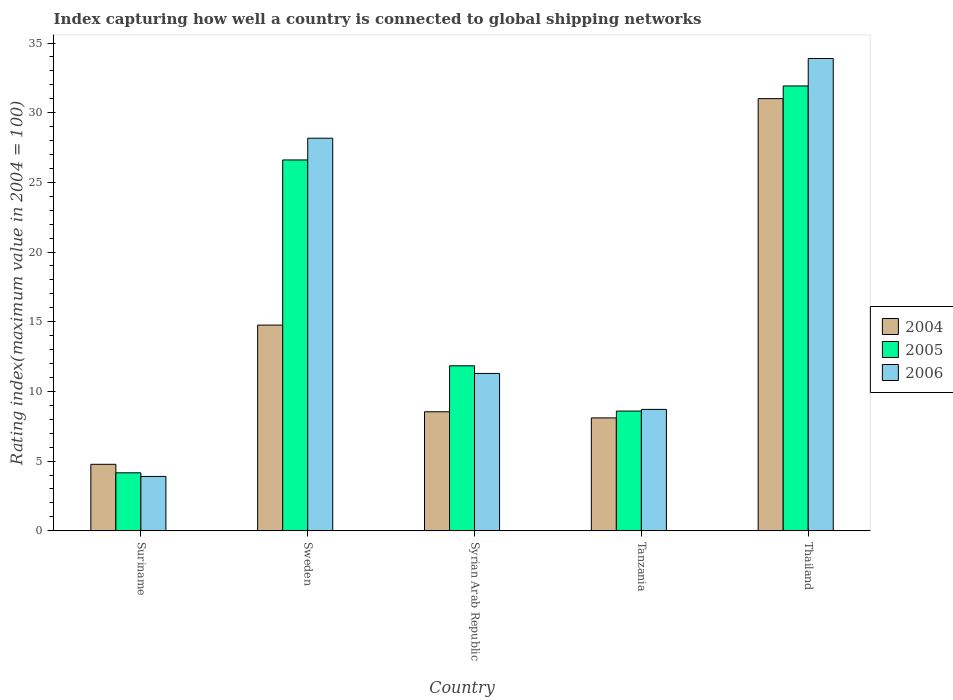How many different coloured bars are there?
Your response must be concise. 3. How many groups of bars are there?
Offer a very short reply. 5. Are the number of bars per tick equal to the number of legend labels?
Keep it short and to the point. Yes. How many bars are there on the 3rd tick from the left?
Offer a terse response. 3. How many bars are there on the 4th tick from the right?
Provide a short and direct response. 3. What is the label of the 1st group of bars from the left?
Provide a short and direct response. Suriname. What is the rating index in 2005 in Tanzania?
Keep it short and to the point. 8.59. Across all countries, what is the maximum rating index in 2006?
Give a very brief answer. 33.89. Across all countries, what is the minimum rating index in 2005?
Provide a succinct answer. 4.16. In which country was the rating index in 2005 maximum?
Offer a terse response. Thailand. In which country was the rating index in 2006 minimum?
Make the answer very short. Suriname. What is the total rating index in 2006 in the graph?
Your response must be concise. 85.96. What is the difference between the rating index in 2005 in Tanzania and that in Thailand?
Offer a very short reply. -23.33. What is the difference between the rating index in 2006 in Syrian Arab Republic and the rating index in 2005 in Tanzania?
Make the answer very short. 2.7. What is the average rating index in 2006 per country?
Give a very brief answer. 17.19. What is the difference between the rating index of/in 2005 and rating index of/in 2006 in Sweden?
Your answer should be compact. -1.56. What is the ratio of the rating index in 2006 in Sweden to that in Tanzania?
Keep it short and to the point. 3.23. Is the difference between the rating index in 2005 in Sweden and Thailand greater than the difference between the rating index in 2006 in Sweden and Thailand?
Provide a succinct answer. Yes. What is the difference between the highest and the second highest rating index in 2004?
Your answer should be very brief. -6.22. What is the difference between the highest and the lowest rating index in 2004?
Your response must be concise. 26.24. Is the sum of the rating index in 2006 in Syrian Arab Republic and Thailand greater than the maximum rating index in 2004 across all countries?
Provide a succinct answer. Yes. What does the 3rd bar from the left in Suriname represents?
Offer a terse response. 2006. What does the 2nd bar from the right in Suriname represents?
Your response must be concise. 2005. Are all the bars in the graph horizontal?
Ensure brevity in your answer.  No. How many countries are there in the graph?
Your answer should be compact. 5. What is the difference between two consecutive major ticks on the Y-axis?
Your response must be concise. 5. Does the graph contain any zero values?
Offer a terse response. No. Where does the legend appear in the graph?
Keep it short and to the point. Center right. How many legend labels are there?
Provide a short and direct response. 3. How are the legend labels stacked?
Give a very brief answer. Vertical. What is the title of the graph?
Your answer should be very brief. Index capturing how well a country is connected to global shipping networks. Does "1974" appear as one of the legend labels in the graph?
Make the answer very short. No. What is the label or title of the Y-axis?
Offer a very short reply. Rating index(maximum value in 2004 = 100). What is the Rating index(maximum value in 2004 = 100) of 2004 in Suriname?
Provide a short and direct response. 4.77. What is the Rating index(maximum value in 2004 = 100) of 2005 in Suriname?
Offer a terse response. 4.16. What is the Rating index(maximum value in 2004 = 100) in 2006 in Suriname?
Your response must be concise. 3.9. What is the Rating index(maximum value in 2004 = 100) of 2004 in Sweden?
Provide a short and direct response. 14.76. What is the Rating index(maximum value in 2004 = 100) of 2005 in Sweden?
Your answer should be compact. 26.61. What is the Rating index(maximum value in 2004 = 100) of 2006 in Sweden?
Provide a succinct answer. 28.17. What is the Rating index(maximum value in 2004 = 100) of 2004 in Syrian Arab Republic?
Keep it short and to the point. 8.54. What is the Rating index(maximum value in 2004 = 100) of 2005 in Syrian Arab Republic?
Your answer should be very brief. 11.84. What is the Rating index(maximum value in 2004 = 100) of 2006 in Syrian Arab Republic?
Offer a very short reply. 11.29. What is the Rating index(maximum value in 2004 = 100) in 2004 in Tanzania?
Ensure brevity in your answer.  8.1. What is the Rating index(maximum value in 2004 = 100) in 2005 in Tanzania?
Your response must be concise. 8.59. What is the Rating index(maximum value in 2004 = 100) of 2006 in Tanzania?
Ensure brevity in your answer.  8.71. What is the Rating index(maximum value in 2004 = 100) of 2004 in Thailand?
Your answer should be very brief. 31.01. What is the Rating index(maximum value in 2004 = 100) in 2005 in Thailand?
Your answer should be very brief. 31.92. What is the Rating index(maximum value in 2004 = 100) in 2006 in Thailand?
Provide a succinct answer. 33.89. Across all countries, what is the maximum Rating index(maximum value in 2004 = 100) in 2004?
Your answer should be very brief. 31.01. Across all countries, what is the maximum Rating index(maximum value in 2004 = 100) of 2005?
Your answer should be compact. 31.92. Across all countries, what is the maximum Rating index(maximum value in 2004 = 100) in 2006?
Offer a very short reply. 33.89. Across all countries, what is the minimum Rating index(maximum value in 2004 = 100) in 2004?
Offer a terse response. 4.77. Across all countries, what is the minimum Rating index(maximum value in 2004 = 100) in 2005?
Ensure brevity in your answer.  4.16. Across all countries, what is the minimum Rating index(maximum value in 2004 = 100) in 2006?
Make the answer very short. 3.9. What is the total Rating index(maximum value in 2004 = 100) of 2004 in the graph?
Ensure brevity in your answer.  67.18. What is the total Rating index(maximum value in 2004 = 100) of 2005 in the graph?
Give a very brief answer. 83.12. What is the total Rating index(maximum value in 2004 = 100) in 2006 in the graph?
Give a very brief answer. 85.96. What is the difference between the Rating index(maximum value in 2004 = 100) in 2004 in Suriname and that in Sweden?
Provide a succinct answer. -9.99. What is the difference between the Rating index(maximum value in 2004 = 100) of 2005 in Suriname and that in Sweden?
Your answer should be compact. -22.45. What is the difference between the Rating index(maximum value in 2004 = 100) in 2006 in Suriname and that in Sweden?
Your answer should be compact. -24.27. What is the difference between the Rating index(maximum value in 2004 = 100) of 2004 in Suriname and that in Syrian Arab Republic?
Keep it short and to the point. -3.77. What is the difference between the Rating index(maximum value in 2004 = 100) of 2005 in Suriname and that in Syrian Arab Republic?
Your answer should be compact. -7.68. What is the difference between the Rating index(maximum value in 2004 = 100) of 2006 in Suriname and that in Syrian Arab Republic?
Make the answer very short. -7.39. What is the difference between the Rating index(maximum value in 2004 = 100) of 2004 in Suriname and that in Tanzania?
Provide a succinct answer. -3.33. What is the difference between the Rating index(maximum value in 2004 = 100) of 2005 in Suriname and that in Tanzania?
Keep it short and to the point. -4.43. What is the difference between the Rating index(maximum value in 2004 = 100) in 2006 in Suriname and that in Tanzania?
Provide a short and direct response. -4.81. What is the difference between the Rating index(maximum value in 2004 = 100) in 2004 in Suriname and that in Thailand?
Make the answer very short. -26.24. What is the difference between the Rating index(maximum value in 2004 = 100) of 2005 in Suriname and that in Thailand?
Give a very brief answer. -27.76. What is the difference between the Rating index(maximum value in 2004 = 100) of 2006 in Suriname and that in Thailand?
Give a very brief answer. -29.99. What is the difference between the Rating index(maximum value in 2004 = 100) in 2004 in Sweden and that in Syrian Arab Republic?
Your answer should be compact. 6.22. What is the difference between the Rating index(maximum value in 2004 = 100) of 2005 in Sweden and that in Syrian Arab Republic?
Your answer should be very brief. 14.77. What is the difference between the Rating index(maximum value in 2004 = 100) of 2006 in Sweden and that in Syrian Arab Republic?
Your answer should be very brief. 16.88. What is the difference between the Rating index(maximum value in 2004 = 100) in 2004 in Sweden and that in Tanzania?
Provide a succinct answer. 6.66. What is the difference between the Rating index(maximum value in 2004 = 100) in 2005 in Sweden and that in Tanzania?
Provide a succinct answer. 18.02. What is the difference between the Rating index(maximum value in 2004 = 100) in 2006 in Sweden and that in Tanzania?
Give a very brief answer. 19.46. What is the difference between the Rating index(maximum value in 2004 = 100) of 2004 in Sweden and that in Thailand?
Provide a short and direct response. -16.25. What is the difference between the Rating index(maximum value in 2004 = 100) in 2005 in Sweden and that in Thailand?
Make the answer very short. -5.31. What is the difference between the Rating index(maximum value in 2004 = 100) of 2006 in Sweden and that in Thailand?
Your response must be concise. -5.72. What is the difference between the Rating index(maximum value in 2004 = 100) of 2004 in Syrian Arab Republic and that in Tanzania?
Provide a short and direct response. 0.44. What is the difference between the Rating index(maximum value in 2004 = 100) of 2005 in Syrian Arab Republic and that in Tanzania?
Your response must be concise. 3.25. What is the difference between the Rating index(maximum value in 2004 = 100) of 2006 in Syrian Arab Republic and that in Tanzania?
Your answer should be compact. 2.58. What is the difference between the Rating index(maximum value in 2004 = 100) of 2004 in Syrian Arab Republic and that in Thailand?
Provide a short and direct response. -22.47. What is the difference between the Rating index(maximum value in 2004 = 100) in 2005 in Syrian Arab Republic and that in Thailand?
Offer a very short reply. -20.08. What is the difference between the Rating index(maximum value in 2004 = 100) in 2006 in Syrian Arab Republic and that in Thailand?
Offer a very short reply. -22.6. What is the difference between the Rating index(maximum value in 2004 = 100) in 2004 in Tanzania and that in Thailand?
Your answer should be compact. -22.91. What is the difference between the Rating index(maximum value in 2004 = 100) in 2005 in Tanzania and that in Thailand?
Offer a very short reply. -23.33. What is the difference between the Rating index(maximum value in 2004 = 100) in 2006 in Tanzania and that in Thailand?
Make the answer very short. -25.18. What is the difference between the Rating index(maximum value in 2004 = 100) in 2004 in Suriname and the Rating index(maximum value in 2004 = 100) in 2005 in Sweden?
Ensure brevity in your answer.  -21.84. What is the difference between the Rating index(maximum value in 2004 = 100) in 2004 in Suriname and the Rating index(maximum value in 2004 = 100) in 2006 in Sweden?
Provide a succinct answer. -23.4. What is the difference between the Rating index(maximum value in 2004 = 100) in 2005 in Suriname and the Rating index(maximum value in 2004 = 100) in 2006 in Sweden?
Give a very brief answer. -24.01. What is the difference between the Rating index(maximum value in 2004 = 100) in 2004 in Suriname and the Rating index(maximum value in 2004 = 100) in 2005 in Syrian Arab Republic?
Keep it short and to the point. -7.07. What is the difference between the Rating index(maximum value in 2004 = 100) in 2004 in Suriname and the Rating index(maximum value in 2004 = 100) in 2006 in Syrian Arab Republic?
Keep it short and to the point. -6.52. What is the difference between the Rating index(maximum value in 2004 = 100) of 2005 in Suriname and the Rating index(maximum value in 2004 = 100) of 2006 in Syrian Arab Republic?
Your answer should be compact. -7.13. What is the difference between the Rating index(maximum value in 2004 = 100) of 2004 in Suriname and the Rating index(maximum value in 2004 = 100) of 2005 in Tanzania?
Make the answer very short. -3.82. What is the difference between the Rating index(maximum value in 2004 = 100) of 2004 in Suriname and the Rating index(maximum value in 2004 = 100) of 2006 in Tanzania?
Make the answer very short. -3.94. What is the difference between the Rating index(maximum value in 2004 = 100) in 2005 in Suriname and the Rating index(maximum value in 2004 = 100) in 2006 in Tanzania?
Offer a very short reply. -4.55. What is the difference between the Rating index(maximum value in 2004 = 100) in 2004 in Suriname and the Rating index(maximum value in 2004 = 100) in 2005 in Thailand?
Keep it short and to the point. -27.15. What is the difference between the Rating index(maximum value in 2004 = 100) of 2004 in Suriname and the Rating index(maximum value in 2004 = 100) of 2006 in Thailand?
Your answer should be very brief. -29.12. What is the difference between the Rating index(maximum value in 2004 = 100) of 2005 in Suriname and the Rating index(maximum value in 2004 = 100) of 2006 in Thailand?
Provide a succinct answer. -29.73. What is the difference between the Rating index(maximum value in 2004 = 100) of 2004 in Sweden and the Rating index(maximum value in 2004 = 100) of 2005 in Syrian Arab Republic?
Offer a terse response. 2.92. What is the difference between the Rating index(maximum value in 2004 = 100) in 2004 in Sweden and the Rating index(maximum value in 2004 = 100) in 2006 in Syrian Arab Republic?
Keep it short and to the point. 3.47. What is the difference between the Rating index(maximum value in 2004 = 100) in 2005 in Sweden and the Rating index(maximum value in 2004 = 100) in 2006 in Syrian Arab Republic?
Offer a terse response. 15.32. What is the difference between the Rating index(maximum value in 2004 = 100) of 2004 in Sweden and the Rating index(maximum value in 2004 = 100) of 2005 in Tanzania?
Your response must be concise. 6.17. What is the difference between the Rating index(maximum value in 2004 = 100) in 2004 in Sweden and the Rating index(maximum value in 2004 = 100) in 2006 in Tanzania?
Give a very brief answer. 6.05. What is the difference between the Rating index(maximum value in 2004 = 100) in 2004 in Sweden and the Rating index(maximum value in 2004 = 100) in 2005 in Thailand?
Make the answer very short. -17.16. What is the difference between the Rating index(maximum value in 2004 = 100) of 2004 in Sweden and the Rating index(maximum value in 2004 = 100) of 2006 in Thailand?
Keep it short and to the point. -19.13. What is the difference between the Rating index(maximum value in 2004 = 100) of 2005 in Sweden and the Rating index(maximum value in 2004 = 100) of 2006 in Thailand?
Offer a very short reply. -7.28. What is the difference between the Rating index(maximum value in 2004 = 100) in 2004 in Syrian Arab Republic and the Rating index(maximum value in 2004 = 100) in 2006 in Tanzania?
Provide a succinct answer. -0.17. What is the difference between the Rating index(maximum value in 2004 = 100) in 2005 in Syrian Arab Republic and the Rating index(maximum value in 2004 = 100) in 2006 in Tanzania?
Give a very brief answer. 3.13. What is the difference between the Rating index(maximum value in 2004 = 100) in 2004 in Syrian Arab Republic and the Rating index(maximum value in 2004 = 100) in 2005 in Thailand?
Give a very brief answer. -23.38. What is the difference between the Rating index(maximum value in 2004 = 100) of 2004 in Syrian Arab Republic and the Rating index(maximum value in 2004 = 100) of 2006 in Thailand?
Offer a very short reply. -25.35. What is the difference between the Rating index(maximum value in 2004 = 100) in 2005 in Syrian Arab Republic and the Rating index(maximum value in 2004 = 100) in 2006 in Thailand?
Provide a succinct answer. -22.05. What is the difference between the Rating index(maximum value in 2004 = 100) in 2004 in Tanzania and the Rating index(maximum value in 2004 = 100) in 2005 in Thailand?
Your answer should be very brief. -23.82. What is the difference between the Rating index(maximum value in 2004 = 100) of 2004 in Tanzania and the Rating index(maximum value in 2004 = 100) of 2006 in Thailand?
Your answer should be very brief. -25.79. What is the difference between the Rating index(maximum value in 2004 = 100) in 2005 in Tanzania and the Rating index(maximum value in 2004 = 100) in 2006 in Thailand?
Your answer should be compact. -25.3. What is the average Rating index(maximum value in 2004 = 100) of 2004 per country?
Your answer should be compact. 13.44. What is the average Rating index(maximum value in 2004 = 100) in 2005 per country?
Provide a succinct answer. 16.62. What is the average Rating index(maximum value in 2004 = 100) of 2006 per country?
Make the answer very short. 17.19. What is the difference between the Rating index(maximum value in 2004 = 100) of 2004 and Rating index(maximum value in 2004 = 100) of 2005 in Suriname?
Make the answer very short. 0.61. What is the difference between the Rating index(maximum value in 2004 = 100) in 2004 and Rating index(maximum value in 2004 = 100) in 2006 in Suriname?
Give a very brief answer. 0.87. What is the difference between the Rating index(maximum value in 2004 = 100) of 2005 and Rating index(maximum value in 2004 = 100) of 2006 in Suriname?
Provide a short and direct response. 0.26. What is the difference between the Rating index(maximum value in 2004 = 100) in 2004 and Rating index(maximum value in 2004 = 100) in 2005 in Sweden?
Ensure brevity in your answer.  -11.85. What is the difference between the Rating index(maximum value in 2004 = 100) of 2004 and Rating index(maximum value in 2004 = 100) of 2006 in Sweden?
Provide a short and direct response. -13.41. What is the difference between the Rating index(maximum value in 2004 = 100) in 2005 and Rating index(maximum value in 2004 = 100) in 2006 in Sweden?
Offer a very short reply. -1.56. What is the difference between the Rating index(maximum value in 2004 = 100) in 2004 and Rating index(maximum value in 2004 = 100) in 2006 in Syrian Arab Republic?
Provide a succinct answer. -2.75. What is the difference between the Rating index(maximum value in 2004 = 100) of 2005 and Rating index(maximum value in 2004 = 100) of 2006 in Syrian Arab Republic?
Ensure brevity in your answer.  0.55. What is the difference between the Rating index(maximum value in 2004 = 100) of 2004 and Rating index(maximum value in 2004 = 100) of 2005 in Tanzania?
Your answer should be very brief. -0.49. What is the difference between the Rating index(maximum value in 2004 = 100) of 2004 and Rating index(maximum value in 2004 = 100) of 2006 in Tanzania?
Provide a succinct answer. -0.61. What is the difference between the Rating index(maximum value in 2004 = 100) of 2005 and Rating index(maximum value in 2004 = 100) of 2006 in Tanzania?
Give a very brief answer. -0.12. What is the difference between the Rating index(maximum value in 2004 = 100) in 2004 and Rating index(maximum value in 2004 = 100) in 2005 in Thailand?
Offer a very short reply. -0.91. What is the difference between the Rating index(maximum value in 2004 = 100) in 2004 and Rating index(maximum value in 2004 = 100) in 2006 in Thailand?
Provide a short and direct response. -2.88. What is the difference between the Rating index(maximum value in 2004 = 100) of 2005 and Rating index(maximum value in 2004 = 100) of 2006 in Thailand?
Your response must be concise. -1.97. What is the ratio of the Rating index(maximum value in 2004 = 100) of 2004 in Suriname to that in Sweden?
Provide a succinct answer. 0.32. What is the ratio of the Rating index(maximum value in 2004 = 100) in 2005 in Suriname to that in Sweden?
Ensure brevity in your answer.  0.16. What is the ratio of the Rating index(maximum value in 2004 = 100) of 2006 in Suriname to that in Sweden?
Give a very brief answer. 0.14. What is the ratio of the Rating index(maximum value in 2004 = 100) in 2004 in Suriname to that in Syrian Arab Republic?
Provide a succinct answer. 0.56. What is the ratio of the Rating index(maximum value in 2004 = 100) of 2005 in Suriname to that in Syrian Arab Republic?
Make the answer very short. 0.35. What is the ratio of the Rating index(maximum value in 2004 = 100) in 2006 in Suriname to that in Syrian Arab Republic?
Provide a short and direct response. 0.35. What is the ratio of the Rating index(maximum value in 2004 = 100) of 2004 in Suriname to that in Tanzania?
Provide a short and direct response. 0.59. What is the ratio of the Rating index(maximum value in 2004 = 100) of 2005 in Suriname to that in Tanzania?
Offer a very short reply. 0.48. What is the ratio of the Rating index(maximum value in 2004 = 100) of 2006 in Suriname to that in Tanzania?
Your response must be concise. 0.45. What is the ratio of the Rating index(maximum value in 2004 = 100) of 2004 in Suriname to that in Thailand?
Your answer should be compact. 0.15. What is the ratio of the Rating index(maximum value in 2004 = 100) in 2005 in Suriname to that in Thailand?
Provide a short and direct response. 0.13. What is the ratio of the Rating index(maximum value in 2004 = 100) of 2006 in Suriname to that in Thailand?
Your answer should be compact. 0.12. What is the ratio of the Rating index(maximum value in 2004 = 100) in 2004 in Sweden to that in Syrian Arab Republic?
Your response must be concise. 1.73. What is the ratio of the Rating index(maximum value in 2004 = 100) in 2005 in Sweden to that in Syrian Arab Republic?
Your answer should be very brief. 2.25. What is the ratio of the Rating index(maximum value in 2004 = 100) in 2006 in Sweden to that in Syrian Arab Republic?
Provide a succinct answer. 2.5. What is the ratio of the Rating index(maximum value in 2004 = 100) in 2004 in Sweden to that in Tanzania?
Your answer should be very brief. 1.82. What is the ratio of the Rating index(maximum value in 2004 = 100) in 2005 in Sweden to that in Tanzania?
Your answer should be very brief. 3.1. What is the ratio of the Rating index(maximum value in 2004 = 100) in 2006 in Sweden to that in Tanzania?
Your response must be concise. 3.23. What is the ratio of the Rating index(maximum value in 2004 = 100) in 2004 in Sweden to that in Thailand?
Make the answer very short. 0.48. What is the ratio of the Rating index(maximum value in 2004 = 100) in 2005 in Sweden to that in Thailand?
Give a very brief answer. 0.83. What is the ratio of the Rating index(maximum value in 2004 = 100) of 2006 in Sweden to that in Thailand?
Provide a short and direct response. 0.83. What is the ratio of the Rating index(maximum value in 2004 = 100) of 2004 in Syrian Arab Republic to that in Tanzania?
Make the answer very short. 1.05. What is the ratio of the Rating index(maximum value in 2004 = 100) of 2005 in Syrian Arab Republic to that in Tanzania?
Make the answer very short. 1.38. What is the ratio of the Rating index(maximum value in 2004 = 100) of 2006 in Syrian Arab Republic to that in Tanzania?
Make the answer very short. 1.3. What is the ratio of the Rating index(maximum value in 2004 = 100) of 2004 in Syrian Arab Republic to that in Thailand?
Offer a very short reply. 0.28. What is the ratio of the Rating index(maximum value in 2004 = 100) of 2005 in Syrian Arab Republic to that in Thailand?
Give a very brief answer. 0.37. What is the ratio of the Rating index(maximum value in 2004 = 100) in 2006 in Syrian Arab Republic to that in Thailand?
Your response must be concise. 0.33. What is the ratio of the Rating index(maximum value in 2004 = 100) in 2004 in Tanzania to that in Thailand?
Make the answer very short. 0.26. What is the ratio of the Rating index(maximum value in 2004 = 100) of 2005 in Tanzania to that in Thailand?
Keep it short and to the point. 0.27. What is the ratio of the Rating index(maximum value in 2004 = 100) of 2006 in Tanzania to that in Thailand?
Give a very brief answer. 0.26. What is the difference between the highest and the second highest Rating index(maximum value in 2004 = 100) of 2004?
Your response must be concise. 16.25. What is the difference between the highest and the second highest Rating index(maximum value in 2004 = 100) of 2005?
Offer a very short reply. 5.31. What is the difference between the highest and the second highest Rating index(maximum value in 2004 = 100) of 2006?
Your answer should be compact. 5.72. What is the difference between the highest and the lowest Rating index(maximum value in 2004 = 100) in 2004?
Your answer should be very brief. 26.24. What is the difference between the highest and the lowest Rating index(maximum value in 2004 = 100) in 2005?
Provide a short and direct response. 27.76. What is the difference between the highest and the lowest Rating index(maximum value in 2004 = 100) in 2006?
Provide a short and direct response. 29.99. 